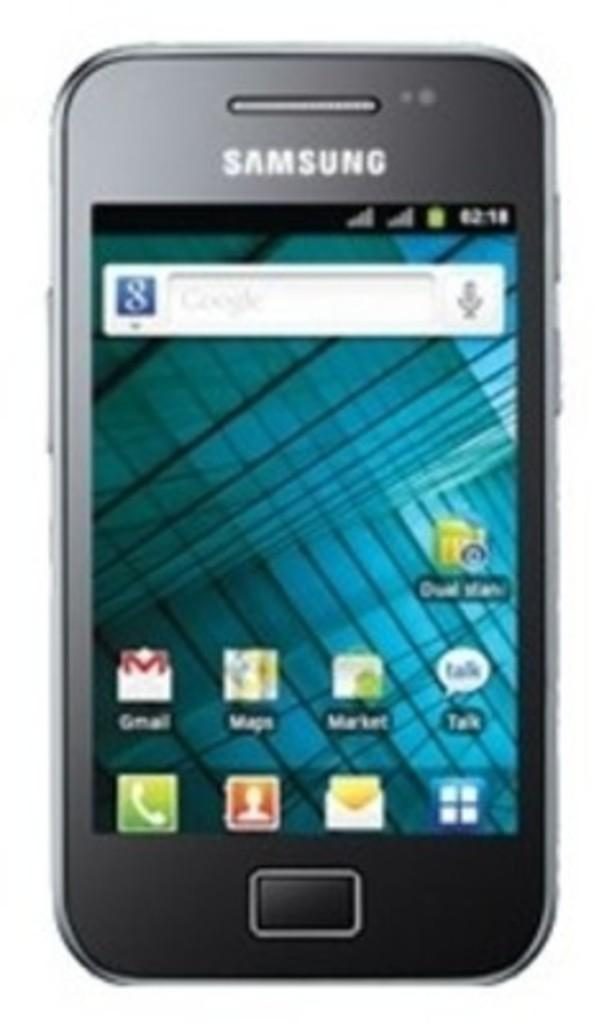<image>
Describe the image concisely. a phone with apps on it from Samsung 